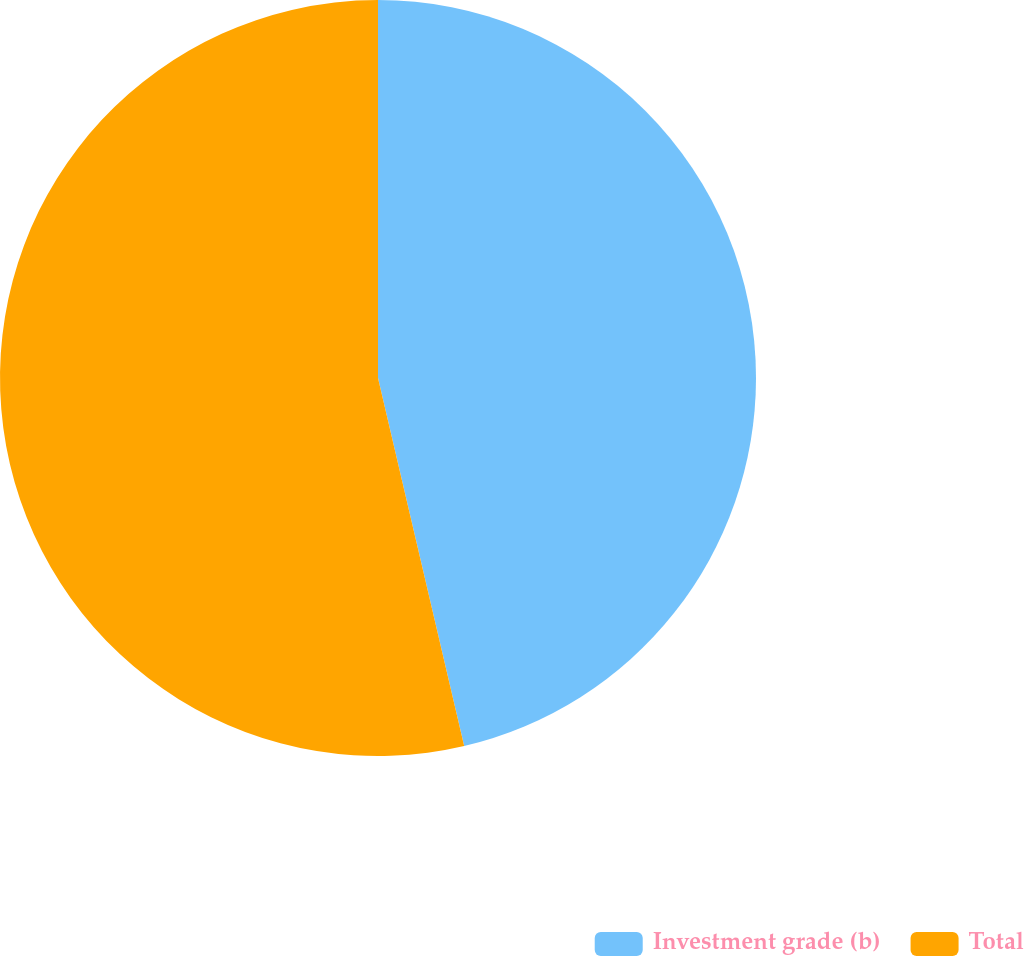Convert chart to OTSL. <chart><loc_0><loc_0><loc_500><loc_500><pie_chart><fcel>Investment grade (b)<fcel>Total<nl><fcel>46.34%<fcel>53.66%<nl></chart> 